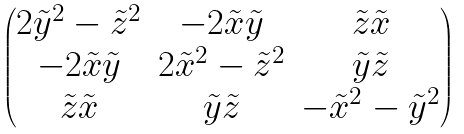Convert formula to latex. <formula><loc_0><loc_0><loc_500><loc_500>\begin{pmatrix} 2 \tilde { y } ^ { 2 } - \tilde { z } ^ { 2 } & - 2 \tilde { x } \tilde { y } & \tilde { z } \tilde { x } \\ - 2 \tilde { x } \tilde { y } & 2 \tilde { x } ^ { 2 } - \tilde { z } ^ { 2 } & \tilde { y } \tilde { z } \\ \tilde { z } \tilde { x } & \tilde { y } \tilde { z } & - \tilde { x } ^ { 2 } - \tilde { y } ^ { 2 } \end{pmatrix}</formula> 